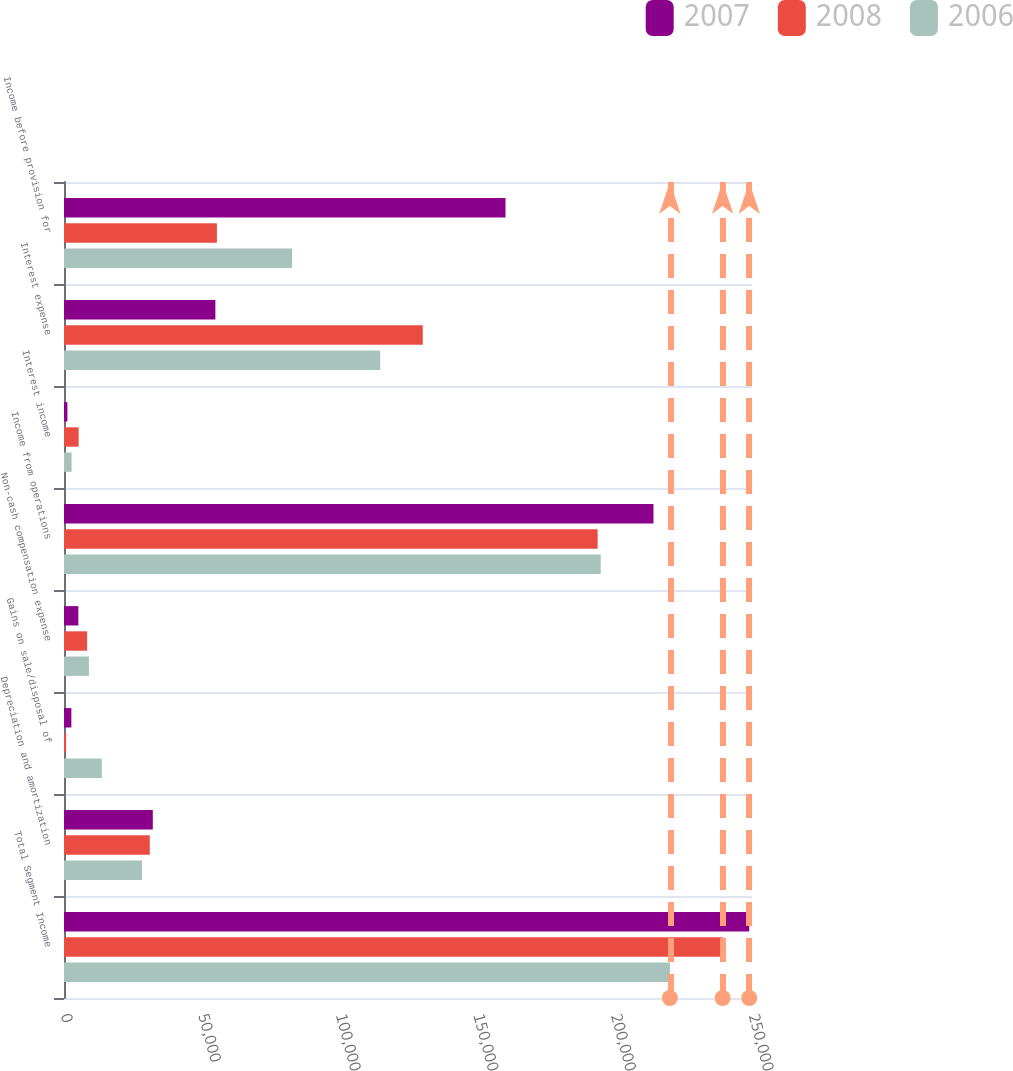Convert chart. <chart><loc_0><loc_0><loc_500><loc_500><stacked_bar_chart><ecel><fcel>Total Segment Income<fcel>Depreciation and amortization<fcel>Gains on sale/disposal of<fcel>Non-cash compensation expense<fcel>Income from operations<fcel>Interest income<fcel>Interest expense<fcel>Income before provision for<nl><fcel>2007<fcel>249003<fcel>32266<fcel>2678<fcel>5218<fcel>214197<fcel>1239<fcel>55011<fcel>160425<nl><fcel>2008<fcel>239326<fcel>31176<fcel>766<fcel>8405<fcel>193910<fcel>5317<fcel>130374<fcel>55559<nl><fcel>2006<fcel>220159<fcel>28377<fcel>13752<fcel>9059<fcel>195030<fcel>2746<fcel>114906<fcel>82870<nl></chart> 